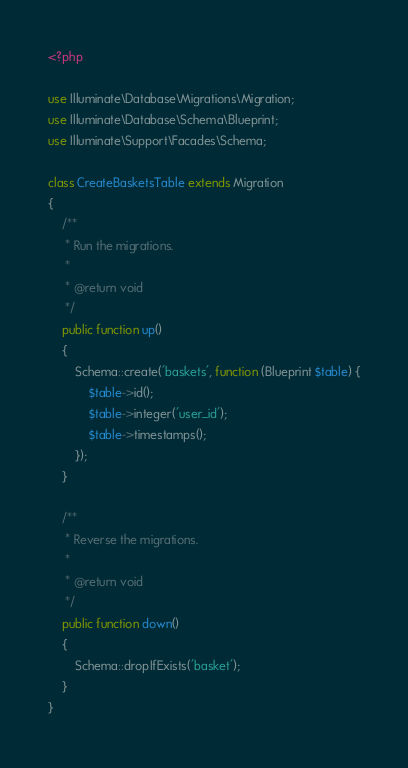Convert code to text. <code><loc_0><loc_0><loc_500><loc_500><_PHP_><?php

use Illuminate\Database\Migrations\Migration;
use Illuminate\Database\Schema\Blueprint;
use Illuminate\Support\Facades\Schema;

class CreateBasketsTable extends Migration
{
    /**
     * Run the migrations.
     *
     * @return void
     */
    public function up()
    {
        Schema::create('baskets', function (Blueprint $table) {
            $table->id();
            $table->integer('user_id');
            $table->timestamps();
        });
    }

    /**
     * Reverse the migrations.
     *
     * @return void
     */
    public function down()
    {
        Schema::dropIfExists('basket');
    }
}
</code> 